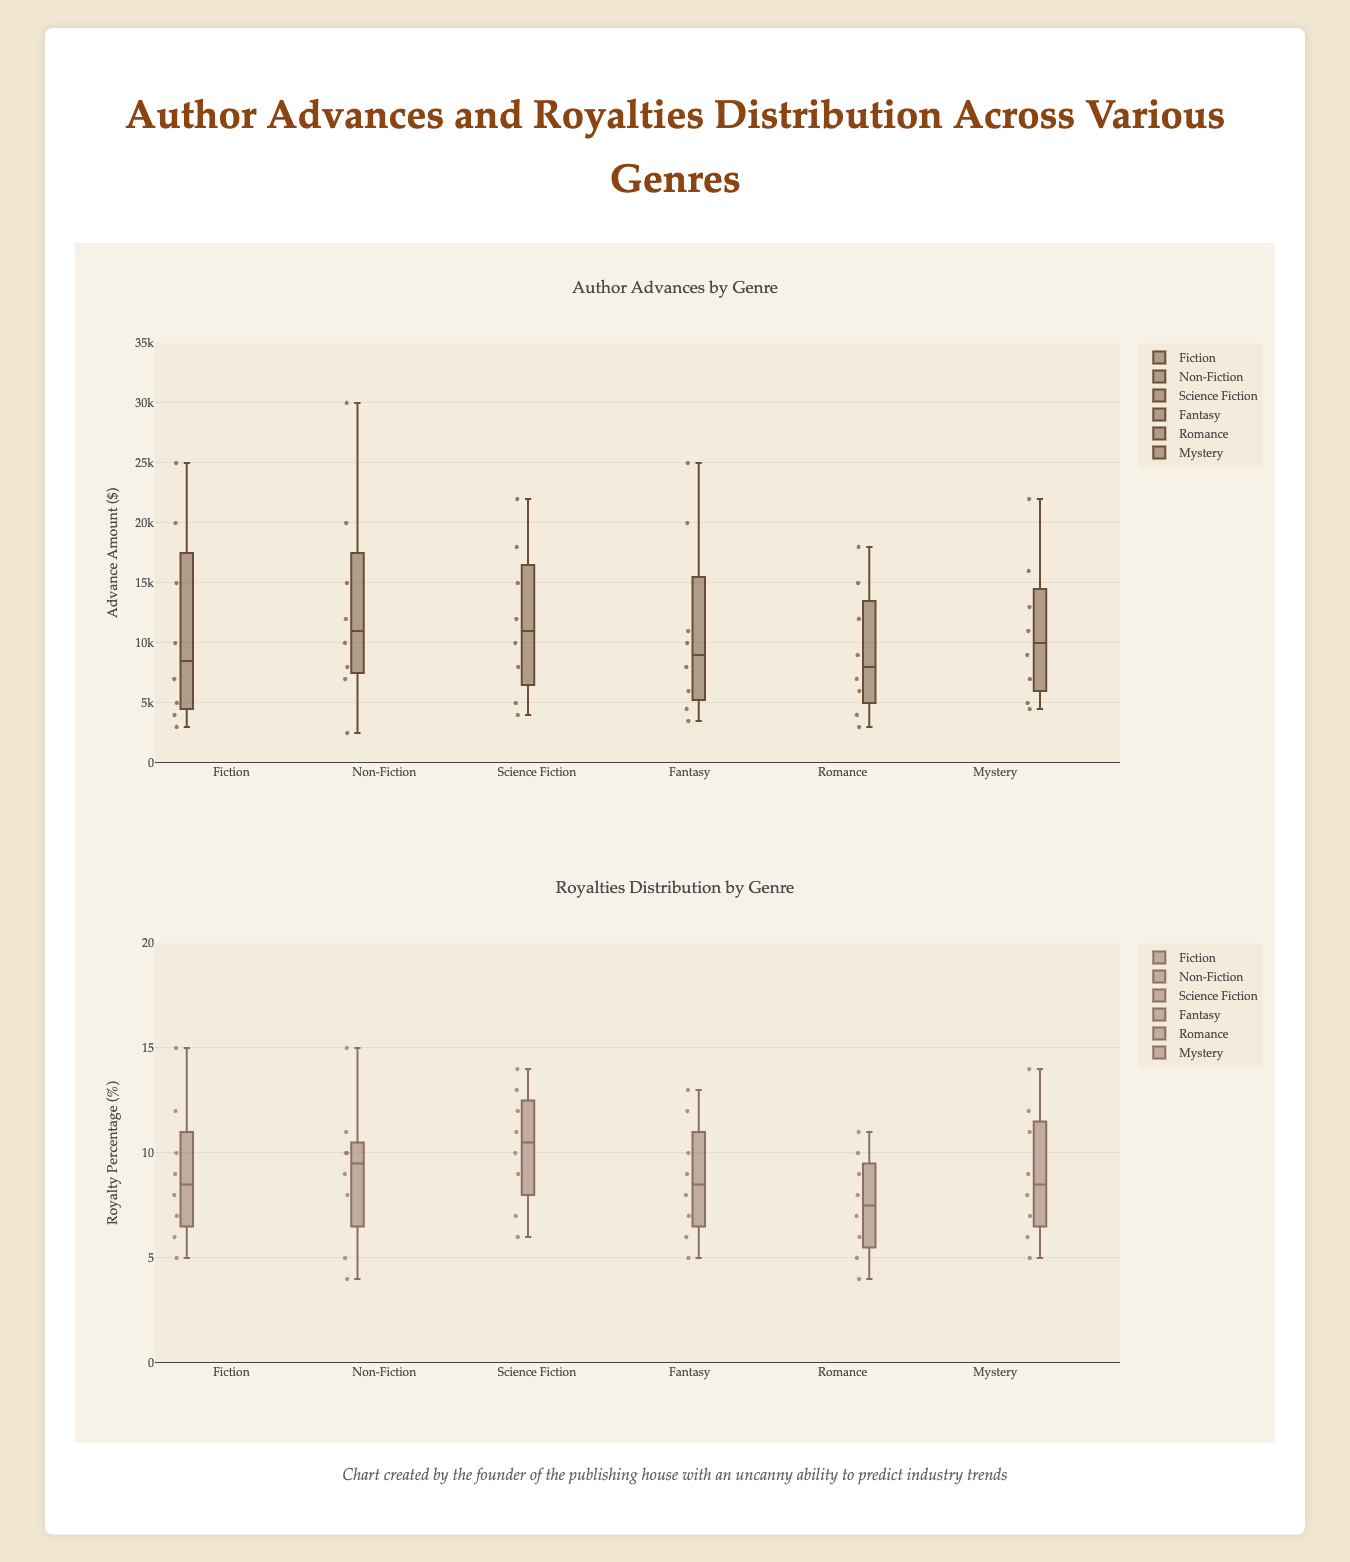How many genres are displayed in the chart? The figure shows six different genre names on the x-axis under "Genres" and has box plots associated with each genre.
Answer: Six What is the highest author advance value in the Non-Fiction genre? In the Non-Fiction box plot, the highest visible point or outlier signifies the highest author advance value. By examining the vertical extent of the Non-Fiction box plot, we find that the highest value is 30,000.
Answer: 30,000 Which genre has the lowest median value for author advances? The median value in a box plot is represented by the line inside the box. Among all genres, the line in the Romance box plot is lower than that in others, indicating the lowest median advance.
Answer: Romance What is the range of the royalties distribution in Science Fiction? The range is calculated by subtracting the minimum value from the maximum value of the box plot for Science Fiction. The lowest value (minimum) is 6% and the highest value (maximum) is 14%. So, the range is 14 - 6 = 8.
Answer: 8 Which genre has the greatest spread in author advances? The spread is determined by the Interquartile Range (IQR), i.e., the range between the bottom and top of the box (Q1 to Q3). Comparing the boxes for all genres, Fantasy has the largest box, indicating the greatest spread.
Answer: Fantasy Between Fantasy and Mystery, which genre has a higher maximum author advance? To determine this, compare the highest points or outliers of the Fantasy and Mystery box plots. The highest point of Fantasy is around 25,000, while that of Mystery is around 22,000. Hence, Fantasy has a higher maximum advance.
Answer: Fantasy What's the interquartile range (IQR) for royalties distribution in Fiction? The IQR is the range between the first quartile (Q1) and the third quartile (Q3). For Fiction, Q1 is at 6% and Q3 is at 10%. Hence, the IQR is 10 - 6 = 4.
Answer: 4 Which genre shows the most outliers in royalties distribution? Outliers in a box plot are points beyond the whiskers. Checking all genres in the royalties distribution plot, Non-Fiction and Science Fiction show similar outliers, but Non-Fiction appears to have more.
Answer: Non-Fiction Compare the median royalties of Romance and Mystery genres. Which one is higher? The median is the line inside the box for each genre. By comparing the lines, the median for Mystery is higher than that for Romance.
Answer: Mystery What is the average royalty percentage in the Fantasy genre? Adding the royalty percentages in Fantasy: (5 + 10 + 13 + 6 + 12 + 8 + 9 + 7) = 70, and dividing by the number of data points 70/8 = 8.75.
Answer: 8.75 